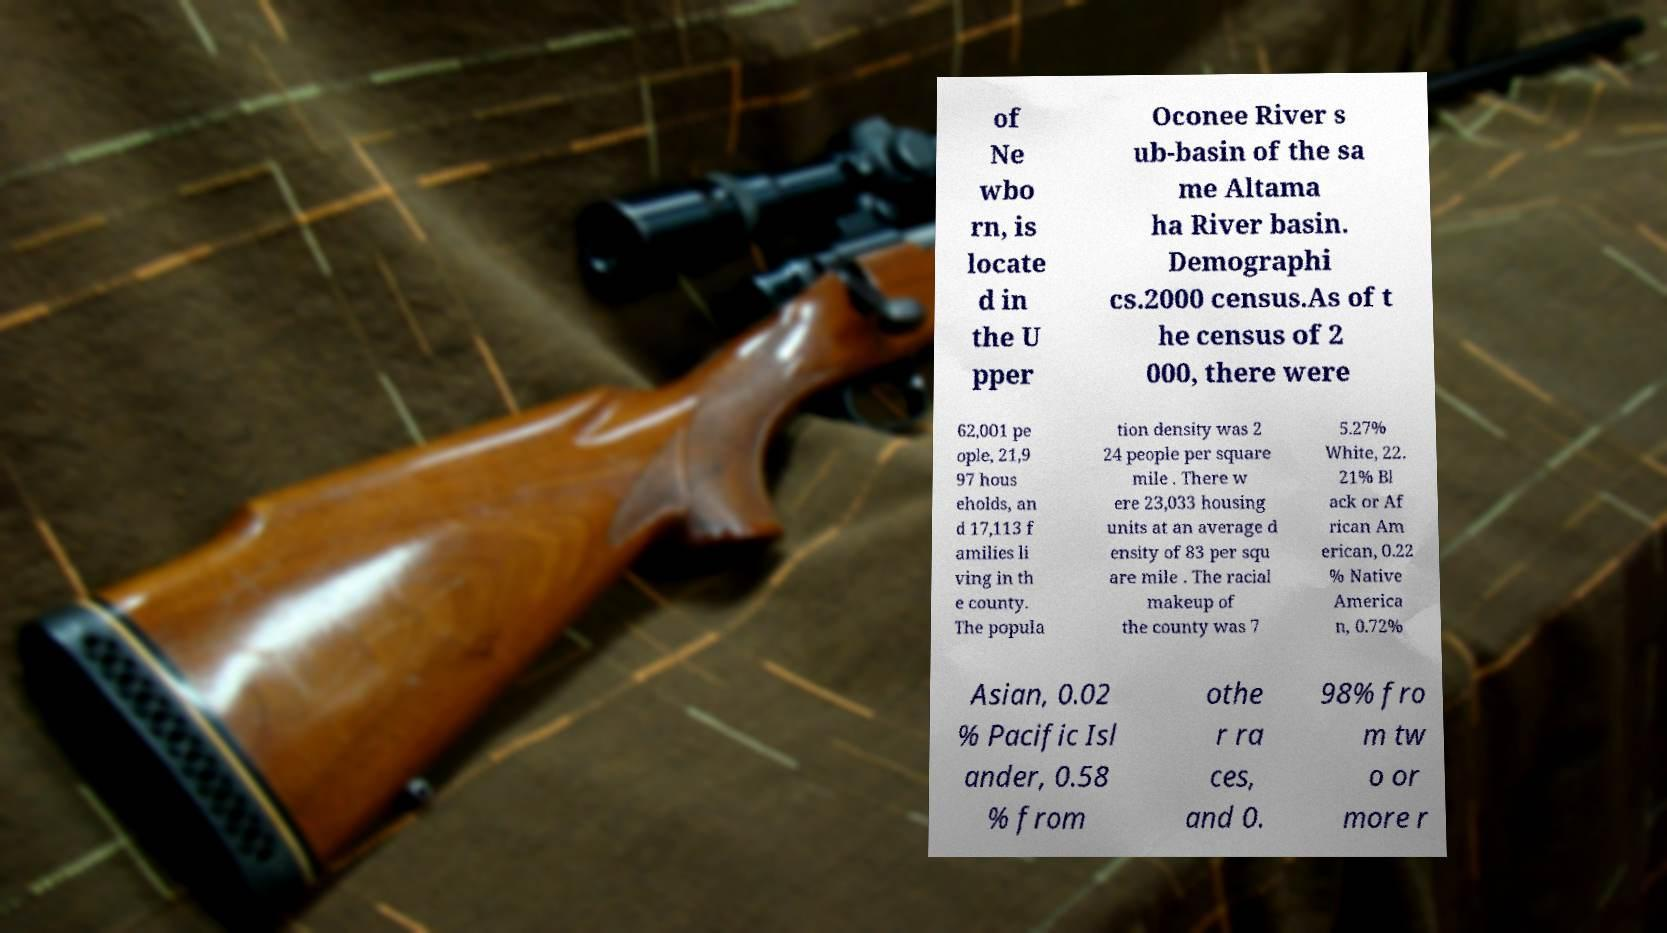Can you read and provide the text displayed in the image?This photo seems to have some interesting text. Can you extract and type it out for me? of Ne wbo rn, is locate d in the U pper Oconee River s ub-basin of the sa me Altama ha River basin. Demographi cs.2000 census.As of t he census of 2 000, there were 62,001 pe ople, 21,9 97 hous eholds, an d 17,113 f amilies li ving in th e county. The popula tion density was 2 24 people per square mile . There w ere 23,033 housing units at an average d ensity of 83 per squ are mile . The racial makeup of the county was 7 5.27% White, 22. 21% Bl ack or Af rican Am erican, 0.22 % Native America n, 0.72% Asian, 0.02 % Pacific Isl ander, 0.58 % from othe r ra ces, and 0. 98% fro m tw o or more r 